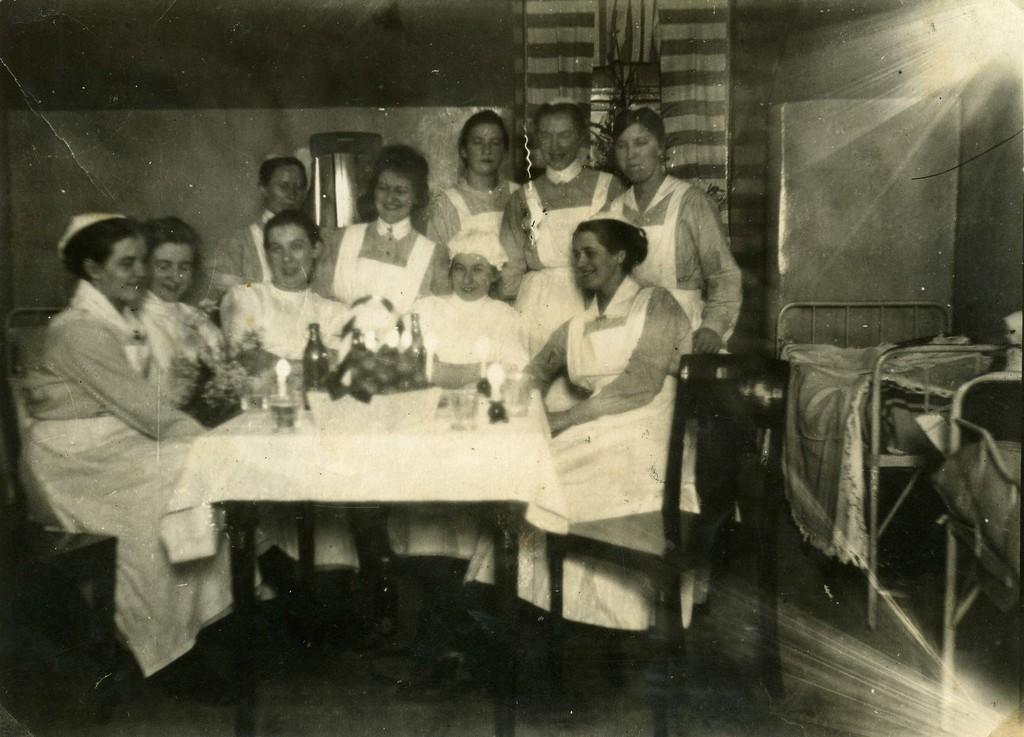Can you describe this image briefly? This is a black and white picture. Here we can see some persons are sitting on the chairs. This is table. On the table there is a cloth, bottle, and a glass. On the background there is a wall and this is floor. 